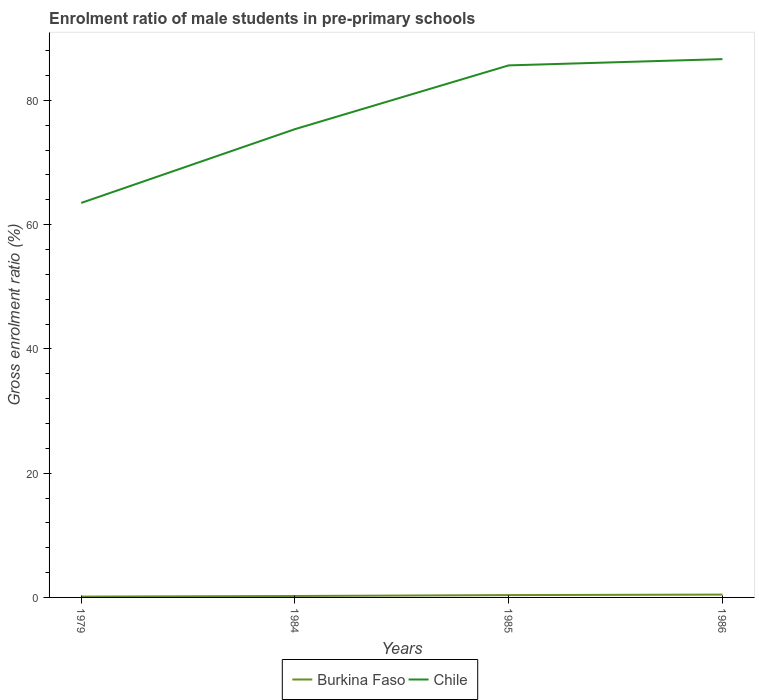How many different coloured lines are there?
Offer a terse response. 2. Does the line corresponding to Chile intersect with the line corresponding to Burkina Faso?
Keep it short and to the point. No. Is the number of lines equal to the number of legend labels?
Keep it short and to the point. Yes. Across all years, what is the maximum enrolment ratio of male students in pre-primary schools in Chile?
Provide a short and direct response. 63.5. In which year was the enrolment ratio of male students in pre-primary schools in Chile maximum?
Offer a terse response. 1979. What is the total enrolment ratio of male students in pre-primary schools in Chile in the graph?
Ensure brevity in your answer.  -22.14. What is the difference between the highest and the second highest enrolment ratio of male students in pre-primary schools in Chile?
Ensure brevity in your answer.  23.15. What is the difference between the highest and the lowest enrolment ratio of male students in pre-primary schools in Burkina Faso?
Your response must be concise. 2. Is the enrolment ratio of male students in pre-primary schools in Burkina Faso strictly greater than the enrolment ratio of male students in pre-primary schools in Chile over the years?
Keep it short and to the point. Yes. What is the difference between two consecutive major ticks on the Y-axis?
Provide a short and direct response. 20. Does the graph contain any zero values?
Keep it short and to the point. No. Does the graph contain grids?
Your answer should be compact. No. Where does the legend appear in the graph?
Ensure brevity in your answer.  Bottom center. How many legend labels are there?
Ensure brevity in your answer.  2. How are the legend labels stacked?
Ensure brevity in your answer.  Horizontal. What is the title of the graph?
Keep it short and to the point. Enrolment ratio of male students in pre-primary schools. What is the Gross enrolment ratio (%) of Burkina Faso in 1979?
Give a very brief answer. 0.14. What is the Gross enrolment ratio (%) in Chile in 1979?
Ensure brevity in your answer.  63.5. What is the Gross enrolment ratio (%) in Burkina Faso in 1984?
Make the answer very short. 0.23. What is the Gross enrolment ratio (%) of Chile in 1984?
Provide a short and direct response. 75.38. What is the Gross enrolment ratio (%) of Burkina Faso in 1985?
Your answer should be very brief. 0.38. What is the Gross enrolment ratio (%) in Chile in 1985?
Ensure brevity in your answer.  85.64. What is the Gross enrolment ratio (%) of Burkina Faso in 1986?
Provide a short and direct response. 0.46. What is the Gross enrolment ratio (%) in Chile in 1986?
Provide a short and direct response. 86.65. Across all years, what is the maximum Gross enrolment ratio (%) in Burkina Faso?
Your response must be concise. 0.46. Across all years, what is the maximum Gross enrolment ratio (%) of Chile?
Keep it short and to the point. 86.65. Across all years, what is the minimum Gross enrolment ratio (%) in Burkina Faso?
Keep it short and to the point. 0.14. Across all years, what is the minimum Gross enrolment ratio (%) of Chile?
Ensure brevity in your answer.  63.5. What is the total Gross enrolment ratio (%) in Burkina Faso in the graph?
Provide a short and direct response. 1.2. What is the total Gross enrolment ratio (%) of Chile in the graph?
Offer a terse response. 311.17. What is the difference between the Gross enrolment ratio (%) in Burkina Faso in 1979 and that in 1984?
Your response must be concise. -0.09. What is the difference between the Gross enrolment ratio (%) of Chile in 1979 and that in 1984?
Keep it short and to the point. -11.88. What is the difference between the Gross enrolment ratio (%) of Burkina Faso in 1979 and that in 1985?
Keep it short and to the point. -0.24. What is the difference between the Gross enrolment ratio (%) in Chile in 1979 and that in 1985?
Your response must be concise. -22.14. What is the difference between the Gross enrolment ratio (%) in Burkina Faso in 1979 and that in 1986?
Your answer should be very brief. -0.32. What is the difference between the Gross enrolment ratio (%) in Chile in 1979 and that in 1986?
Your answer should be compact. -23.15. What is the difference between the Gross enrolment ratio (%) in Burkina Faso in 1984 and that in 1985?
Give a very brief answer. -0.14. What is the difference between the Gross enrolment ratio (%) of Chile in 1984 and that in 1985?
Make the answer very short. -10.26. What is the difference between the Gross enrolment ratio (%) in Burkina Faso in 1984 and that in 1986?
Your response must be concise. -0.23. What is the difference between the Gross enrolment ratio (%) of Chile in 1984 and that in 1986?
Offer a terse response. -11.27. What is the difference between the Gross enrolment ratio (%) in Burkina Faso in 1985 and that in 1986?
Offer a very short reply. -0.08. What is the difference between the Gross enrolment ratio (%) in Chile in 1985 and that in 1986?
Make the answer very short. -1.01. What is the difference between the Gross enrolment ratio (%) in Burkina Faso in 1979 and the Gross enrolment ratio (%) in Chile in 1984?
Your answer should be very brief. -75.24. What is the difference between the Gross enrolment ratio (%) of Burkina Faso in 1979 and the Gross enrolment ratio (%) of Chile in 1985?
Keep it short and to the point. -85.5. What is the difference between the Gross enrolment ratio (%) of Burkina Faso in 1979 and the Gross enrolment ratio (%) of Chile in 1986?
Offer a very short reply. -86.51. What is the difference between the Gross enrolment ratio (%) of Burkina Faso in 1984 and the Gross enrolment ratio (%) of Chile in 1985?
Your answer should be compact. -85.41. What is the difference between the Gross enrolment ratio (%) of Burkina Faso in 1984 and the Gross enrolment ratio (%) of Chile in 1986?
Offer a very short reply. -86.42. What is the difference between the Gross enrolment ratio (%) in Burkina Faso in 1985 and the Gross enrolment ratio (%) in Chile in 1986?
Offer a terse response. -86.27. What is the average Gross enrolment ratio (%) in Burkina Faso per year?
Provide a succinct answer. 0.3. What is the average Gross enrolment ratio (%) of Chile per year?
Provide a succinct answer. 77.79. In the year 1979, what is the difference between the Gross enrolment ratio (%) in Burkina Faso and Gross enrolment ratio (%) in Chile?
Provide a short and direct response. -63.36. In the year 1984, what is the difference between the Gross enrolment ratio (%) in Burkina Faso and Gross enrolment ratio (%) in Chile?
Provide a succinct answer. -75.15. In the year 1985, what is the difference between the Gross enrolment ratio (%) of Burkina Faso and Gross enrolment ratio (%) of Chile?
Provide a succinct answer. -85.26. In the year 1986, what is the difference between the Gross enrolment ratio (%) of Burkina Faso and Gross enrolment ratio (%) of Chile?
Make the answer very short. -86.19. What is the ratio of the Gross enrolment ratio (%) of Burkina Faso in 1979 to that in 1984?
Provide a succinct answer. 0.6. What is the ratio of the Gross enrolment ratio (%) in Chile in 1979 to that in 1984?
Your answer should be compact. 0.84. What is the ratio of the Gross enrolment ratio (%) of Burkina Faso in 1979 to that in 1985?
Your response must be concise. 0.37. What is the ratio of the Gross enrolment ratio (%) of Chile in 1979 to that in 1985?
Your answer should be compact. 0.74. What is the ratio of the Gross enrolment ratio (%) in Burkina Faso in 1979 to that in 1986?
Your answer should be very brief. 0.3. What is the ratio of the Gross enrolment ratio (%) in Chile in 1979 to that in 1986?
Provide a succinct answer. 0.73. What is the ratio of the Gross enrolment ratio (%) in Burkina Faso in 1984 to that in 1985?
Your answer should be compact. 0.61. What is the ratio of the Gross enrolment ratio (%) of Chile in 1984 to that in 1985?
Keep it short and to the point. 0.88. What is the ratio of the Gross enrolment ratio (%) of Burkina Faso in 1984 to that in 1986?
Offer a terse response. 0.5. What is the ratio of the Gross enrolment ratio (%) of Chile in 1984 to that in 1986?
Provide a succinct answer. 0.87. What is the ratio of the Gross enrolment ratio (%) of Burkina Faso in 1985 to that in 1986?
Your answer should be very brief. 0.82. What is the ratio of the Gross enrolment ratio (%) of Chile in 1985 to that in 1986?
Your response must be concise. 0.99. What is the difference between the highest and the second highest Gross enrolment ratio (%) in Burkina Faso?
Offer a terse response. 0.08. What is the difference between the highest and the second highest Gross enrolment ratio (%) in Chile?
Offer a terse response. 1.01. What is the difference between the highest and the lowest Gross enrolment ratio (%) in Burkina Faso?
Ensure brevity in your answer.  0.32. What is the difference between the highest and the lowest Gross enrolment ratio (%) of Chile?
Your answer should be compact. 23.15. 